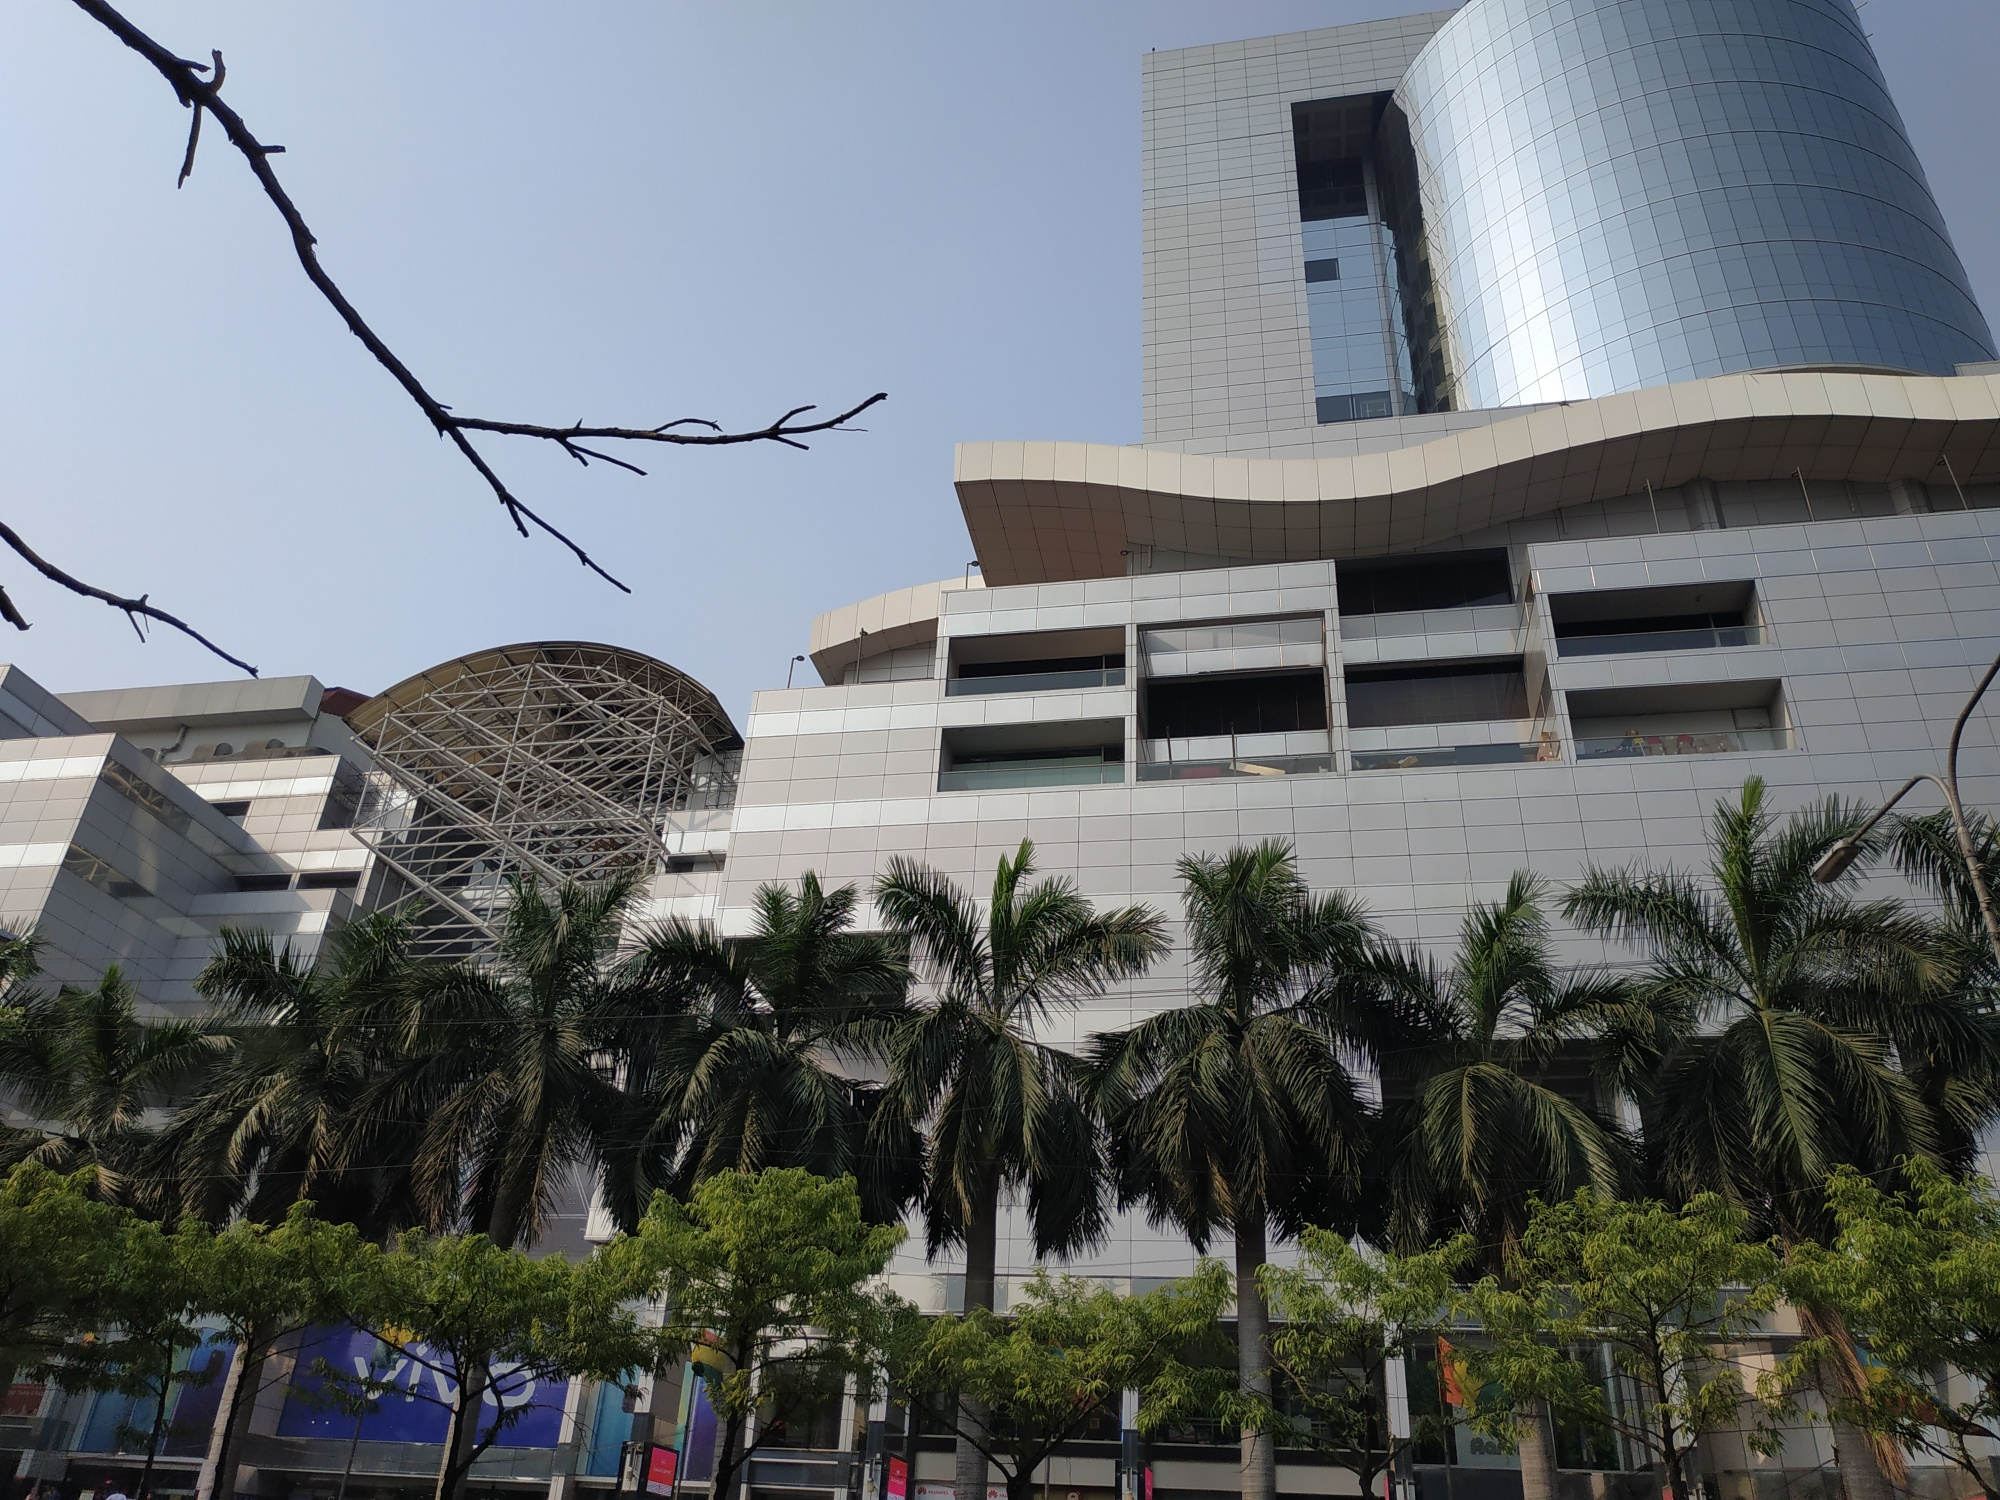What are the key elements in this picture? The image prominently showcases the impressive facade of the Ion Orchard shopping mall in Singapore, a well-known landmark. The building's modern architectural design stands out with a shimmering, curved glass facade that catches the sunlight beautifully. A distinctive metal dome further enhances the structure's futuristic look, making it a visual centerpiece. The photograph is taken from a low-angle perspective, emphasizing the height and grandeur of the building. In the foreground, lush palm trees and leafy green trees add a contrast of nature against the sleek urban architecture, blending the urban landscape with touches of greenery. This image vividly captures the intersection of cutting-edge architecture and natural elements in this vibrant city-state. 